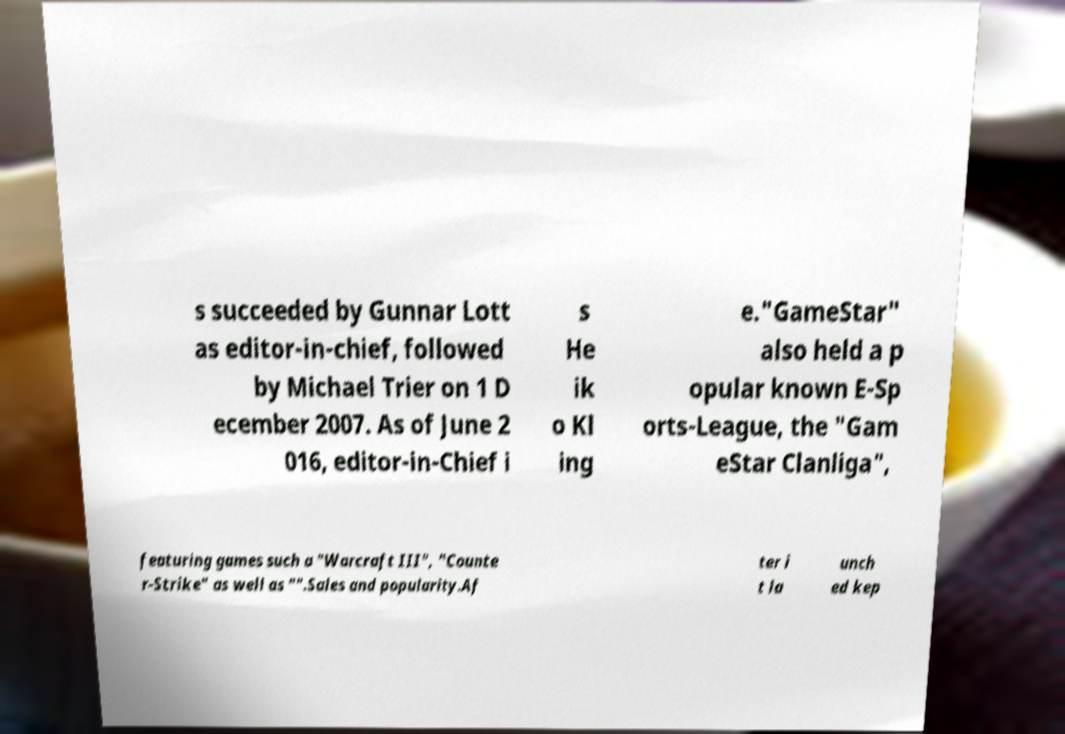Could you extract and type out the text from this image? s succeeded by Gunnar Lott as editor-in-chief, followed by Michael Trier on 1 D ecember 2007. As of June 2 016, editor-in-Chief i s He ik o Kl ing e."GameStar" also held a p opular known E-Sp orts-League, the "Gam eStar Clanliga", featuring games such a "Warcraft III", "Counte r-Strike" as well as "".Sales and popularity.Af ter i t la unch ed kep 